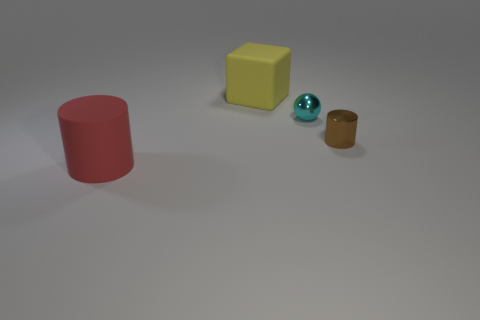Add 3 large matte blocks. How many objects exist? 7 Subtract 0 blue balls. How many objects are left? 4 Subtract all spheres. How many objects are left? 3 Subtract 1 blocks. How many blocks are left? 0 Subtract all green cylinders. Subtract all blue balls. How many cylinders are left? 2 Subtract all gray blocks. How many red balls are left? 0 Subtract all brown metal objects. Subtract all tiny cyan shiny balls. How many objects are left? 2 Add 4 big rubber cylinders. How many big rubber cylinders are left? 5 Add 1 red matte blocks. How many red matte blocks exist? 1 Subtract all red cylinders. How many cylinders are left? 1 